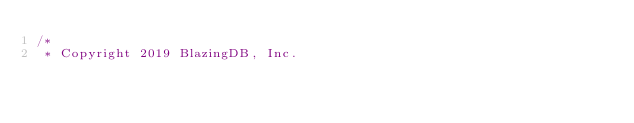<code> <loc_0><loc_0><loc_500><loc_500><_Cuda_>/*
 * Copyright 2019 BlazingDB, Inc.</code> 